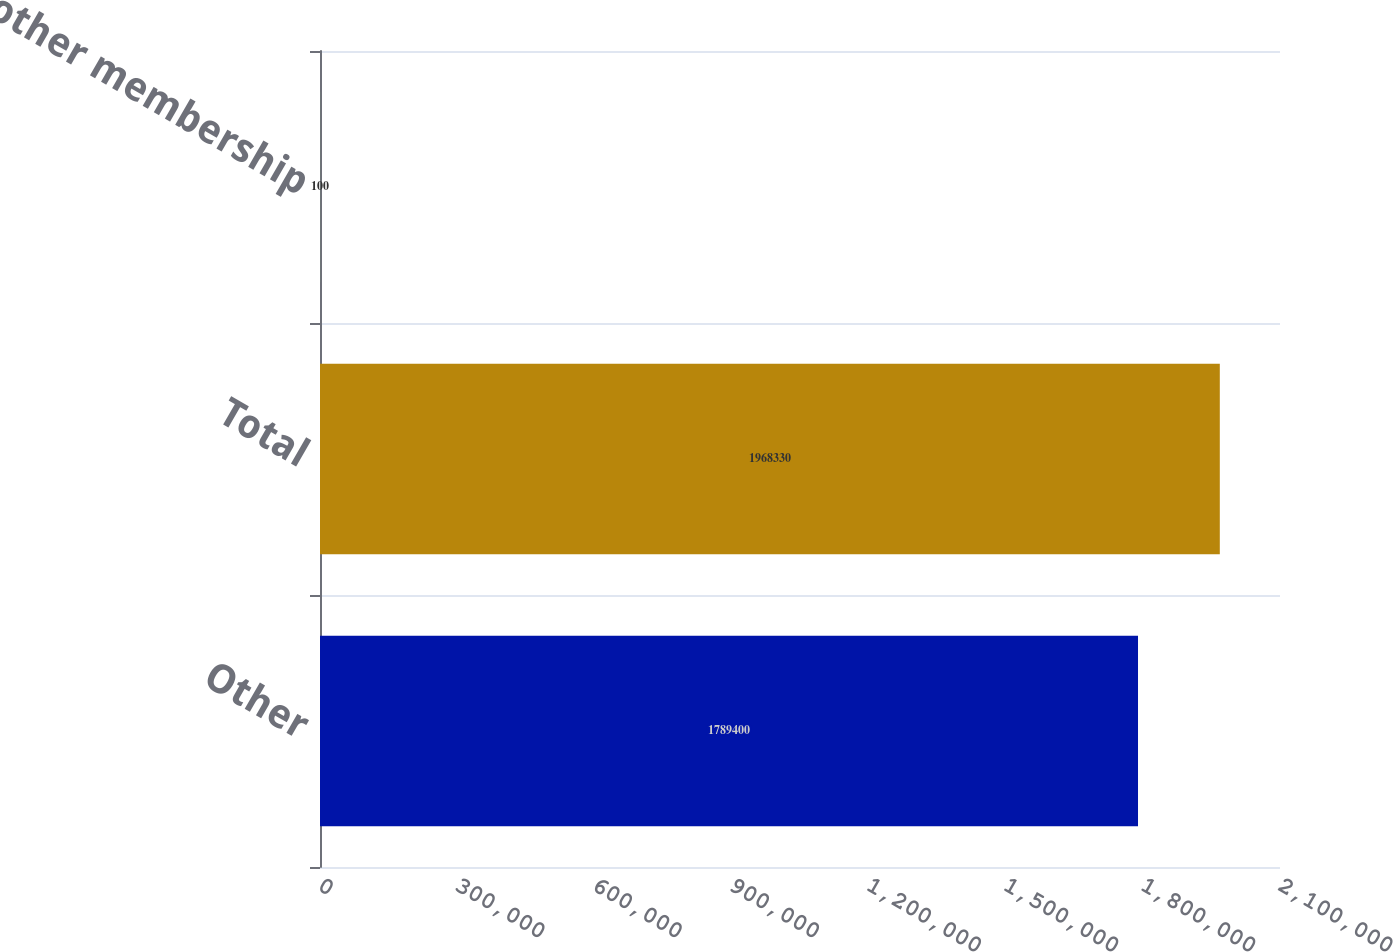Convert chart to OTSL. <chart><loc_0><loc_0><loc_500><loc_500><bar_chart><fcel>Other<fcel>Total<fcel>All other membership<nl><fcel>1.7894e+06<fcel>1.96833e+06<fcel>100<nl></chart> 